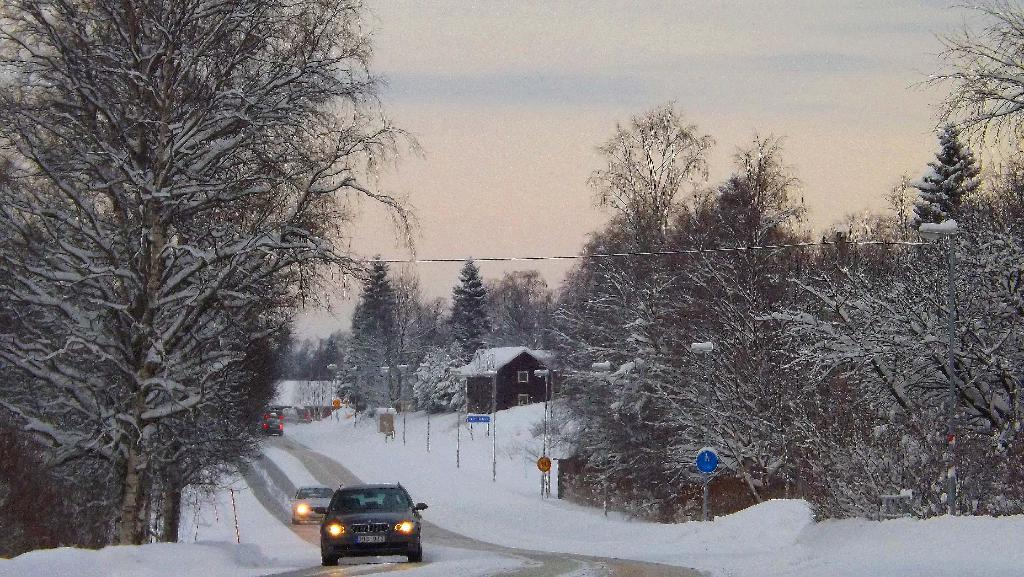What can be seen on the road in the image? There are cars on the road in the image. What type of vegetation is present on both sides of the road? There are trees on either side of the road. What is covering the ground in the image? The ground is covered in snow. What structures can be seen on the right side of the image? There are buildings on the right side of the image. What part of the natural environment is visible in the image? The sky is visible above the scene. Can you see an umbrella being used in the image? There is no umbrella present in the image. What type of pie is being served in the image? There is no pie present in the image. 